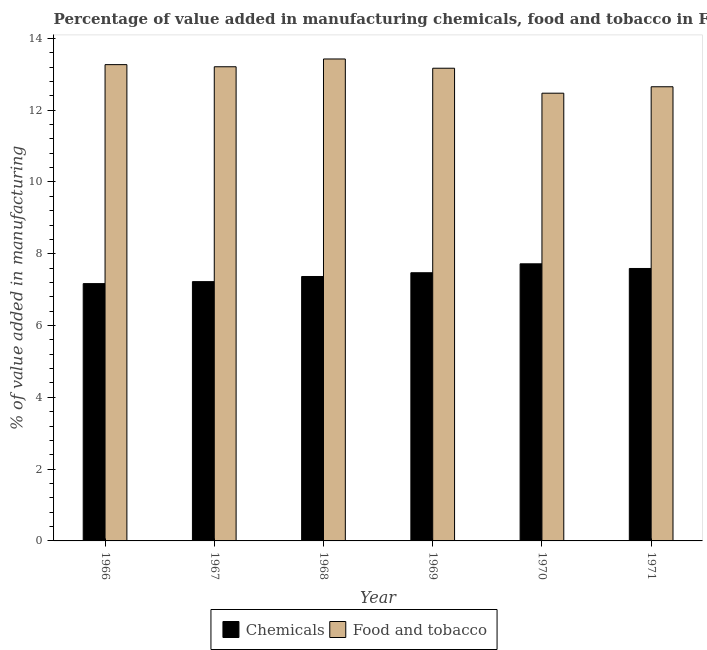Are the number of bars per tick equal to the number of legend labels?
Make the answer very short. Yes. Are the number of bars on each tick of the X-axis equal?
Your answer should be compact. Yes. How many bars are there on the 5th tick from the left?
Provide a succinct answer. 2. How many bars are there on the 6th tick from the right?
Keep it short and to the point. 2. What is the label of the 3rd group of bars from the left?
Provide a succinct answer. 1968. In how many cases, is the number of bars for a given year not equal to the number of legend labels?
Make the answer very short. 0. What is the value added by  manufacturing chemicals in 1970?
Keep it short and to the point. 7.72. Across all years, what is the maximum value added by manufacturing food and tobacco?
Provide a succinct answer. 13.43. Across all years, what is the minimum value added by  manufacturing chemicals?
Offer a very short reply. 7.17. In which year was the value added by manufacturing food and tobacco maximum?
Offer a terse response. 1968. In which year was the value added by  manufacturing chemicals minimum?
Your answer should be compact. 1966. What is the total value added by  manufacturing chemicals in the graph?
Ensure brevity in your answer.  44.53. What is the difference between the value added by  manufacturing chemicals in 1968 and that in 1969?
Offer a very short reply. -0.1. What is the difference between the value added by manufacturing food and tobacco in 1967 and the value added by  manufacturing chemicals in 1970?
Your response must be concise. 0.74. What is the average value added by  manufacturing chemicals per year?
Offer a terse response. 7.42. In the year 1967, what is the difference between the value added by manufacturing food and tobacco and value added by  manufacturing chemicals?
Your answer should be compact. 0. In how many years, is the value added by manufacturing food and tobacco greater than 2 %?
Your response must be concise. 6. What is the ratio of the value added by manufacturing food and tobacco in 1966 to that in 1970?
Give a very brief answer. 1.06. What is the difference between the highest and the second highest value added by manufacturing food and tobacco?
Your answer should be compact. 0.16. What is the difference between the highest and the lowest value added by manufacturing food and tobacco?
Your answer should be very brief. 0.95. In how many years, is the value added by manufacturing food and tobacco greater than the average value added by manufacturing food and tobacco taken over all years?
Offer a terse response. 4. What does the 1st bar from the left in 1968 represents?
Your answer should be compact. Chemicals. What does the 2nd bar from the right in 1968 represents?
Offer a very short reply. Chemicals. How many bars are there?
Make the answer very short. 12. Are all the bars in the graph horizontal?
Ensure brevity in your answer.  No. What is the difference between two consecutive major ticks on the Y-axis?
Offer a terse response. 2. Does the graph contain any zero values?
Make the answer very short. No. Does the graph contain grids?
Keep it short and to the point. No. Where does the legend appear in the graph?
Offer a terse response. Bottom center. What is the title of the graph?
Provide a short and direct response. Percentage of value added in manufacturing chemicals, food and tobacco in France. Does "Birth rate" appear as one of the legend labels in the graph?
Offer a terse response. No. What is the label or title of the X-axis?
Your response must be concise. Year. What is the label or title of the Y-axis?
Your answer should be very brief. % of value added in manufacturing. What is the % of value added in manufacturing of Chemicals in 1966?
Ensure brevity in your answer.  7.17. What is the % of value added in manufacturing of Food and tobacco in 1966?
Your response must be concise. 13.27. What is the % of value added in manufacturing in Chemicals in 1967?
Your answer should be compact. 7.22. What is the % of value added in manufacturing of Food and tobacco in 1967?
Ensure brevity in your answer.  13.21. What is the % of value added in manufacturing in Chemicals in 1968?
Your answer should be compact. 7.37. What is the % of value added in manufacturing of Food and tobacco in 1968?
Provide a succinct answer. 13.43. What is the % of value added in manufacturing in Chemicals in 1969?
Give a very brief answer. 7.47. What is the % of value added in manufacturing of Food and tobacco in 1969?
Give a very brief answer. 13.17. What is the % of value added in manufacturing in Chemicals in 1970?
Provide a succinct answer. 7.72. What is the % of value added in manufacturing of Food and tobacco in 1970?
Provide a succinct answer. 12.47. What is the % of value added in manufacturing in Chemicals in 1971?
Give a very brief answer. 7.59. What is the % of value added in manufacturing in Food and tobacco in 1971?
Offer a terse response. 12.65. Across all years, what is the maximum % of value added in manufacturing of Chemicals?
Make the answer very short. 7.72. Across all years, what is the maximum % of value added in manufacturing in Food and tobacco?
Your answer should be compact. 13.43. Across all years, what is the minimum % of value added in manufacturing in Chemicals?
Your answer should be very brief. 7.17. Across all years, what is the minimum % of value added in manufacturing of Food and tobacco?
Your answer should be very brief. 12.47. What is the total % of value added in manufacturing of Chemicals in the graph?
Offer a very short reply. 44.53. What is the total % of value added in manufacturing of Food and tobacco in the graph?
Offer a terse response. 78.19. What is the difference between the % of value added in manufacturing in Chemicals in 1966 and that in 1967?
Make the answer very short. -0.06. What is the difference between the % of value added in manufacturing in Food and tobacco in 1966 and that in 1967?
Provide a short and direct response. 0.06. What is the difference between the % of value added in manufacturing in Chemicals in 1966 and that in 1968?
Offer a very short reply. -0.2. What is the difference between the % of value added in manufacturing of Food and tobacco in 1966 and that in 1968?
Provide a short and direct response. -0.16. What is the difference between the % of value added in manufacturing of Chemicals in 1966 and that in 1969?
Offer a very short reply. -0.3. What is the difference between the % of value added in manufacturing in Food and tobacco in 1966 and that in 1969?
Your answer should be compact. 0.1. What is the difference between the % of value added in manufacturing in Chemicals in 1966 and that in 1970?
Your response must be concise. -0.55. What is the difference between the % of value added in manufacturing of Food and tobacco in 1966 and that in 1970?
Your response must be concise. 0.8. What is the difference between the % of value added in manufacturing of Chemicals in 1966 and that in 1971?
Your response must be concise. -0.42. What is the difference between the % of value added in manufacturing of Food and tobacco in 1966 and that in 1971?
Offer a terse response. 0.62. What is the difference between the % of value added in manufacturing in Chemicals in 1967 and that in 1968?
Make the answer very short. -0.14. What is the difference between the % of value added in manufacturing of Food and tobacco in 1967 and that in 1968?
Your answer should be compact. -0.22. What is the difference between the % of value added in manufacturing of Chemicals in 1967 and that in 1969?
Your response must be concise. -0.25. What is the difference between the % of value added in manufacturing in Food and tobacco in 1967 and that in 1969?
Your answer should be very brief. 0.04. What is the difference between the % of value added in manufacturing of Chemicals in 1967 and that in 1970?
Give a very brief answer. -0.5. What is the difference between the % of value added in manufacturing of Food and tobacco in 1967 and that in 1970?
Your answer should be very brief. 0.74. What is the difference between the % of value added in manufacturing in Chemicals in 1967 and that in 1971?
Your response must be concise. -0.37. What is the difference between the % of value added in manufacturing in Food and tobacco in 1967 and that in 1971?
Provide a succinct answer. 0.56. What is the difference between the % of value added in manufacturing of Chemicals in 1968 and that in 1969?
Give a very brief answer. -0.1. What is the difference between the % of value added in manufacturing of Food and tobacco in 1968 and that in 1969?
Ensure brevity in your answer.  0.26. What is the difference between the % of value added in manufacturing in Chemicals in 1968 and that in 1970?
Your answer should be very brief. -0.35. What is the difference between the % of value added in manufacturing in Food and tobacco in 1968 and that in 1970?
Your response must be concise. 0.95. What is the difference between the % of value added in manufacturing in Chemicals in 1968 and that in 1971?
Make the answer very short. -0.22. What is the difference between the % of value added in manufacturing in Food and tobacco in 1968 and that in 1971?
Your answer should be compact. 0.77. What is the difference between the % of value added in manufacturing of Chemicals in 1969 and that in 1970?
Your answer should be very brief. -0.25. What is the difference between the % of value added in manufacturing in Food and tobacco in 1969 and that in 1970?
Offer a terse response. 0.7. What is the difference between the % of value added in manufacturing in Chemicals in 1969 and that in 1971?
Your answer should be very brief. -0.12. What is the difference between the % of value added in manufacturing in Food and tobacco in 1969 and that in 1971?
Offer a very short reply. 0.52. What is the difference between the % of value added in manufacturing in Chemicals in 1970 and that in 1971?
Your answer should be compact. 0.13. What is the difference between the % of value added in manufacturing of Food and tobacco in 1970 and that in 1971?
Offer a very short reply. -0.18. What is the difference between the % of value added in manufacturing of Chemicals in 1966 and the % of value added in manufacturing of Food and tobacco in 1967?
Offer a very short reply. -6.04. What is the difference between the % of value added in manufacturing of Chemicals in 1966 and the % of value added in manufacturing of Food and tobacco in 1968?
Your answer should be very brief. -6.26. What is the difference between the % of value added in manufacturing of Chemicals in 1966 and the % of value added in manufacturing of Food and tobacco in 1969?
Your response must be concise. -6. What is the difference between the % of value added in manufacturing of Chemicals in 1966 and the % of value added in manufacturing of Food and tobacco in 1970?
Your answer should be compact. -5.3. What is the difference between the % of value added in manufacturing in Chemicals in 1966 and the % of value added in manufacturing in Food and tobacco in 1971?
Provide a short and direct response. -5.48. What is the difference between the % of value added in manufacturing in Chemicals in 1967 and the % of value added in manufacturing in Food and tobacco in 1968?
Make the answer very short. -6.2. What is the difference between the % of value added in manufacturing in Chemicals in 1967 and the % of value added in manufacturing in Food and tobacco in 1969?
Ensure brevity in your answer.  -5.94. What is the difference between the % of value added in manufacturing of Chemicals in 1967 and the % of value added in manufacturing of Food and tobacco in 1970?
Your answer should be compact. -5.25. What is the difference between the % of value added in manufacturing of Chemicals in 1967 and the % of value added in manufacturing of Food and tobacco in 1971?
Make the answer very short. -5.43. What is the difference between the % of value added in manufacturing of Chemicals in 1968 and the % of value added in manufacturing of Food and tobacco in 1969?
Your response must be concise. -5.8. What is the difference between the % of value added in manufacturing in Chemicals in 1968 and the % of value added in manufacturing in Food and tobacco in 1970?
Provide a succinct answer. -5.11. What is the difference between the % of value added in manufacturing of Chemicals in 1968 and the % of value added in manufacturing of Food and tobacco in 1971?
Your response must be concise. -5.29. What is the difference between the % of value added in manufacturing of Chemicals in 1969 and the % of value added in manufacturing of Food and tobacco in 1970?
Keep it short and to the point. -5. What is the difference between the % of value added in manufacturing in Chemicals in 1969 and the % of value added in manufacturing in Food and tobacco in 1971?
Provide a succinct answer. -5.18. What is the difference between the % of value added in manufacturing of Chemicals in 1970 and the % of value added in manufacturing of Food and tobacco in 1971?
Provide a short and direct response. -4.93. What is the average % of value added in manufacturing of Chemicals per year?
Make the answer very short. 7.42. What is the average % of value added in manufacturing of Food and tobacco per year?
Offer a terse response. 13.03. In the year 1966, what is the difference between the % of value added in manufacturing in Chemicals and % of value added in manufacturing in Food and tobacco?
Keep it short and to the point. -6.1. In the year 1967, what is the difference between the % of value added in manufacturing in Chemicals and % of value added in manufacturing in Food and tobacco?
Provide a succinct answer. -5.99. In the year 1968, what is the difference between the % of value added in manufacturing of Chemicals and % of value added in manufacturing of Food and tobacco?
Keep it short and to the point. -6.06. In the year 1969, what is the difference between the % of value added in manufacturing of Chemicals and % of value added in manufacturing of Food and tobacco?
Give a very brief answer. -5.7. In the year 1970, what is the difference between the % of value added in manufacturing in Chemicals and % of value added in manufacturing in Food and tobacco?
Provide a succinct answer. -4.75. In the year 1971, what is the difference between the % of value added in manufacturing in Chemicals and % of value added in manufacturing in Food and tobacco?
Your answer should be compact. -5.06. What is the ratio of the % of value added in manufacturing of Food and tobacco in 1966 to that in 1967?
Your answer should be compact. 1. What is the ratio of the % of value added in manufacturing of Chemicals in 1966 to that in 1968?
Your answer should be compact. 0.97. What is the ratio of the % of value added in manufacturing of Food and tobacco in 1966 to that in 1968?
Keep it short and to the point. 0.99. What is the ratio of the % of value added in manufacturing in Chemicals in 1966 to that in 1969?
Your answer should be compact. 0.96. What is the ratio of the % of value added in manufacturing in Food and tobacco in 1966 to that in 1969?
Ensure brevity in your answer.  1.01. What is the ratio of the % of value added in manufacturing of Food and tobacco in 1966 to that in 1970?
Ensure brevity in your answer.  1.06. What is the ratio of the % of value added in manufacturing in Food and tobacco in 1966 to that in 1971?
Your answer should be compact. 1.05. What is the ratio of the % of value added in manufacturing of Chemicals in 1967 to that in 1968?
Provide a succinct answer. 0.98. What is the ratio of the % of value added in manufacturing of Food and tobacco in 1967 to that in 1968?
Offer a very short reply. 0.98. What is the ratio of the % of value added in manufacturing of Chemicals in 1967 to that in 1969?
Offer a terse response. 0.97. What is the ratio of the % of value added in manufacturing of Food and tobacco in 1967 to that in 1969?
Ensure brevity in your answer.  1. What is the ratio of the % of value added in manufacturing in Chemicals in 1967 to that in 1970?
Offer a terse response. 0.94. What is the ratio of the % of value added in manufacturing of Food and tobacco in 1967 to that in 1970?
Offer a terse response. 1.06. What is the ratio of the % of value added in manufacturing in Chemicals in 1967 to that in 1971?
Ensure brevity in your answer.  0.95. What is the ratio of the % of value added in manufacturing of Food and tobacco in 1967 to that in 1971?
Provide a succinct answer. 1.04. What is the ratio of the % of value added in manufacturing of Chemicals in 1968 to that in 1969?
Keep it short and to the point. 0.99. What is the ratio of the % of value added in manufacturing in Food and tobacco in 1968 to that in 1969?
Provide a succinct answer. 1.02. What is the ratio of the % of value added in manufacturing in Chemicals in 1968 to that in 1970?
Your answer should be very brief. 0.95. What is the ratio of the % of value added in manufacturing in Food and tobacco in 1968 to that in 1970?
Provide a succinct answer. 1.08. What is the ratio of the % of value added in manufacturing of Chemicals in 1968 to that in 1971?
Make the answer very short. 0.97. What is the ratio of the % of value added in manufacturing in Food and tobacco in 1968 to that in 1971?
Provide a short and direct response. 1.06. What is the ratio of the % of value added in manufacturing of Chemicals in 1969 to that in 1970?
Keep it short and to the point. 0.97. What is the ratio of the % of value added in manufacturing of Food and tobacco in 1969 to that in 1970?
Give a very brief answer. 1.06. What is the ratio of the % of value added in manufacturing of Chemicals in 1969 to that in 1971?
Your response must be concise. 0.98. What is the ratio of the % of value added in manufacturing of Food and tobacco in 1969 to that in 1971?
Your answer should be very brief. 1.04. What is the ratio of the % of value added in manufacturing in Chemicals in 1970 to that in 1971?
Your answer should be very brief. 1.02. What is the ratio of the % of value added in manufacturing of Food and tobacco in 1970 to that in 1971?
Offer a terse response. 0.99. What is the difference between the highest and the second highest % of value added in manufacturing of Chemicals?
Make the answer very short. 0.13. What is the difference between the highest and the second highest % of value added in manufacturing of Food and tobacco?
Offer a terse response. 0.16. What is the difference between the highest and the lowest % of value added in manufacturing in Chemicals?
Ensure brevity in your answer.  0.55. What is the difference between the highest and the lowest % of value added in manufacturing of Food and tobacco?
Keep it short and to the point. 0.95. 